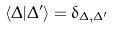Convert formula to latex. <formula><loc_0><loc_0><loc_500><loc_500>\langle \Delta | \Delta ^ { \prime } \rangle = \delta _ { \Delta , \Delta ^ { \prime } }</formula> 